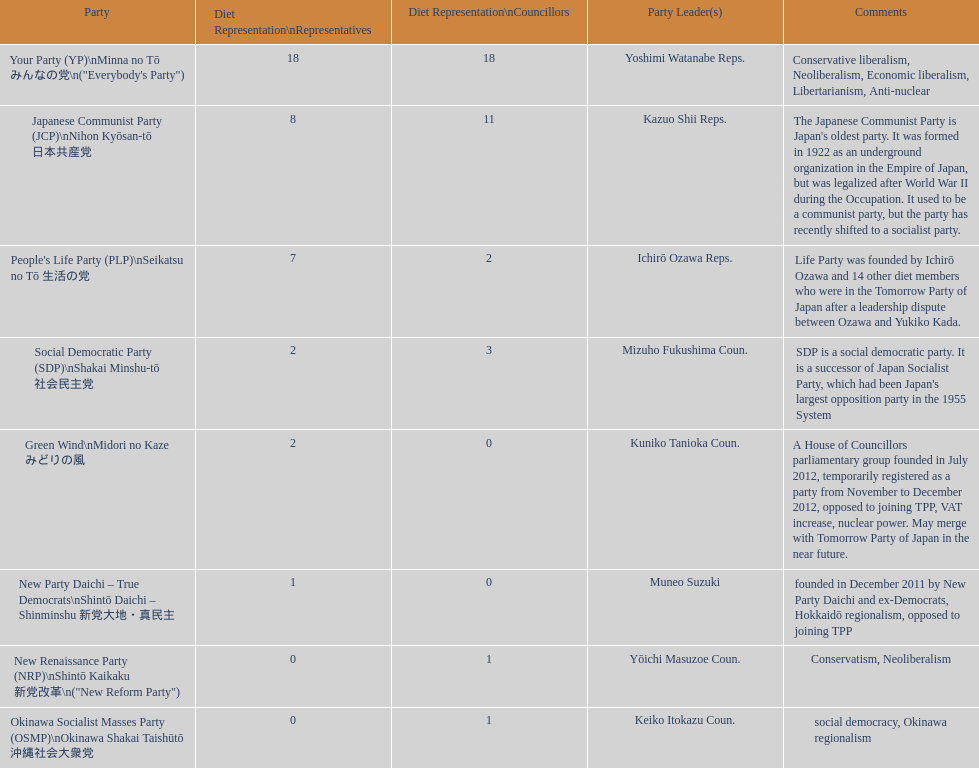What is the highest number of party leaders allowed in the people's life party? 1. 